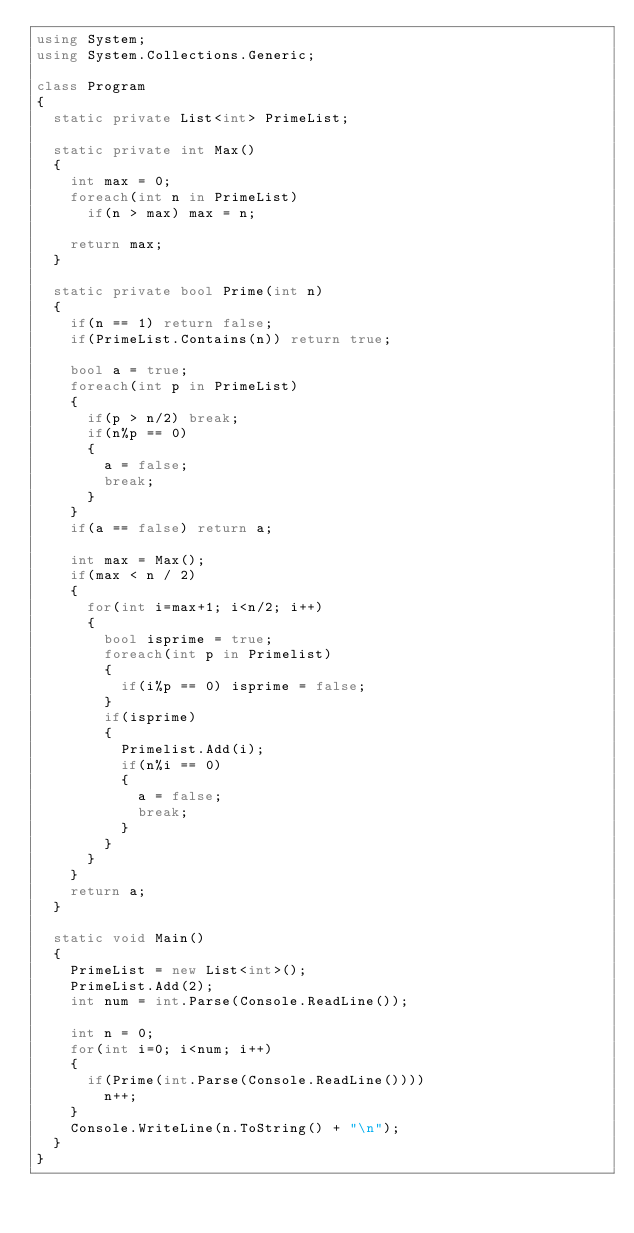Convert code to text. <code><loc_0><loc_0><loc_500><loc_500><_C#_>using System;
using System.Collections.Generic;

class Program
{
	static private List<int> PrimeList;

	static private int Max()
	{
		int max = 0;
		foreach(int n in PrimeList)
			if(n > max) max = n;

		return max;
	}

	static private bool Prime(int n)
	{
		if(n == 1) return false;
		if(PrimeList.Contains(n)) return true;

		bool a = true;
		foreach(int p in PrimeList)
		{
			if(p > n/2) break;
			if(n%p == 0)
			{
				a = false;
				break;
			}
		}
		if(a == false) return a;

		int max = Max();
		if(max < n / 2)
		{
			for(int i=max+1; i<n/2; i++)
			{
				bool isprime = true;
				foreach(int p in Primelist)
				{
					if(i%p == 0) isprime = false;
				}
				if(isprime)
				{
					Primelist.Add(i);
					if(n%i == 0)
					{
						a = false;
						break;
					}
				}
			}
		}
		return a;
	}

	static void Main() 
	{
		PrimeList = new List<int>();
		PrimeList.Add(2);
		int num = int.Parse(Console.ReadLine());

		int n = 0;
		for(int i=0; i<num; i++)
		{
			if(Prime(int.Parse(Console.ReadLine())))
				n++;
		}
		Console.WriteLine(n.ToString() + "\n");
	}
}</code> 